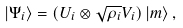<formula> <loc_0><loc_0><loc_500><loc_500>\left | \Psi _ { i } \right \rangle = ( U _ { i } \otimes \sqrt { \rho _ { i } } V _ { i } ) \left | m \right \rangle ,</formula> 